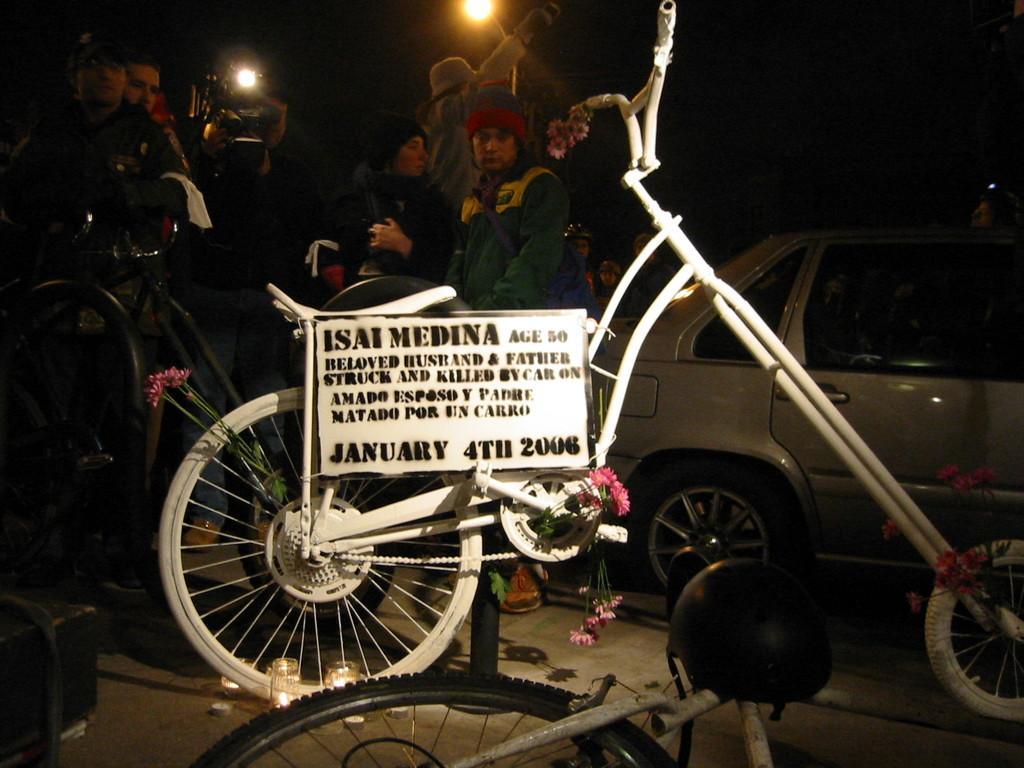Could you give a brief overview of what you see in this image? In this image we can see bicycles, a car, few people, a person is holding a camera, there are few flowers and a board with text attached to the bicycle and there is a helmet on the bicycle and there are few objects on the ground and there is a street light in the background. 